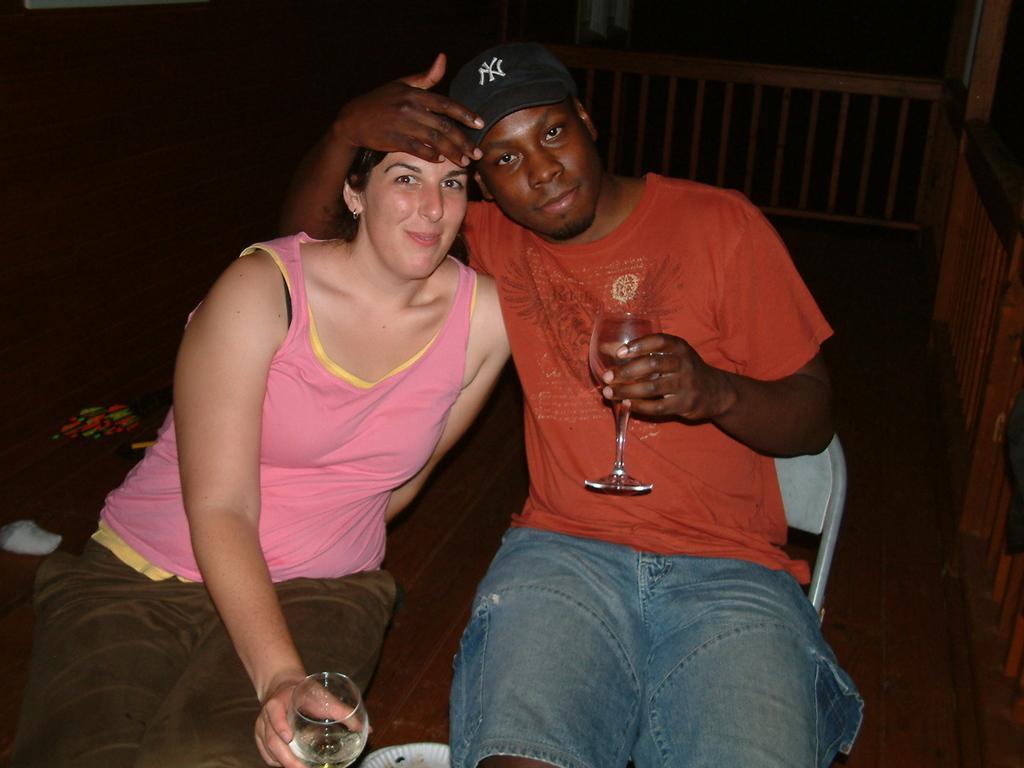Please provide a concise description of this image. In this image I can see a man is sitting on the chair. The woman is sitting and there are holding the glass. The man is wearing the black cap. At the background we can see wooden fencing which is in brown color. 